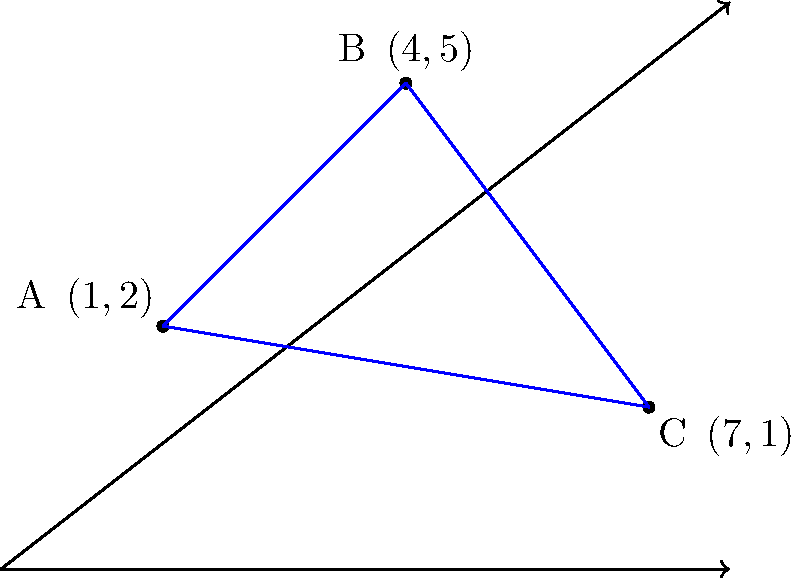In the coordinate plane, three points are given: A(1,2), B(4,5), and C(7,1). Calculate the area of the triangle formed by these points. To find the area of a triangle given three points, we can use the formula:

$$\text{Area} = \frac{1}{2}|x_1(y_2 - y_3) + x_2(y_3 - y_1) + x_3(y_1 - y_2)|$$

Where $(x_1, y_1)$, $(x_2, y_2)$, and $(x_3, y_3)$ are the coordinates of the three points.

Step 1: Identify the coordinates:
A(1,2), B(4,5), C(7,1)

Step 2: Plug the values into the formula:
$$\text{Area} = \frac{1}{2}|1(5 - 1) + 4(1 - 2) + 7(2 - 5)|$$

Step 3: Simplify the expression inside the absolute value bars:
$$\text{Area} = \frac{1}{2}|1(4) + 4(-1) + 7(-3)|$$
$$\text{Area} = \frac{1}{2}|4 - 4 - 21|$$
$$\text{Area} = \frac{1}{2}|-21|$$

Step 4: Calculate the final result:
$$\text{Area} = \frac{1}{2}(21) = 10.5$$

Therefore, the area of the triangle is 10.5 square units.
Answer: 10.5 square units 